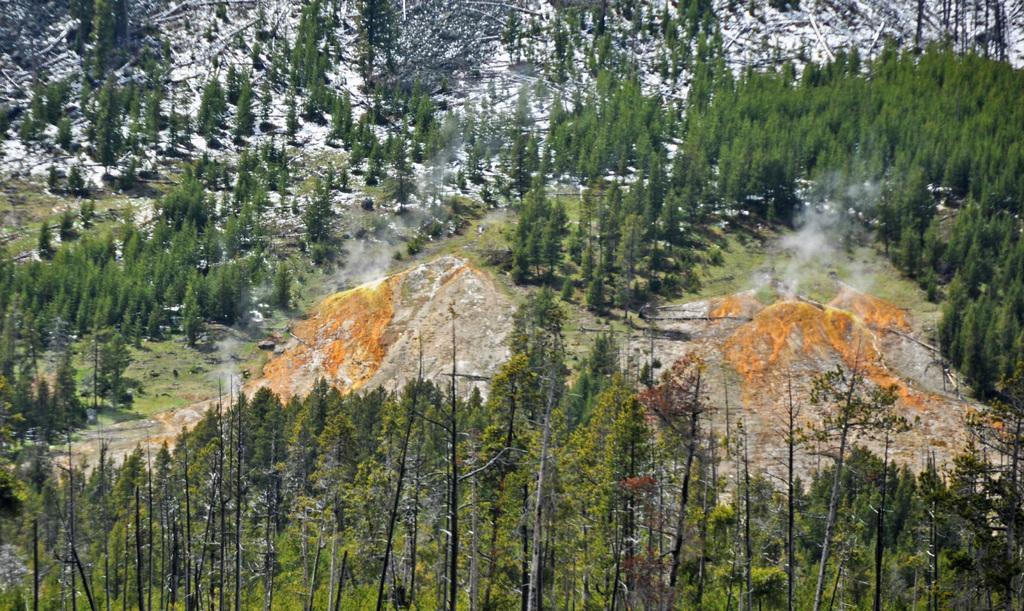Can you describe this image briefly? In this image we can see trees, plants, ground, snow on the hill. 